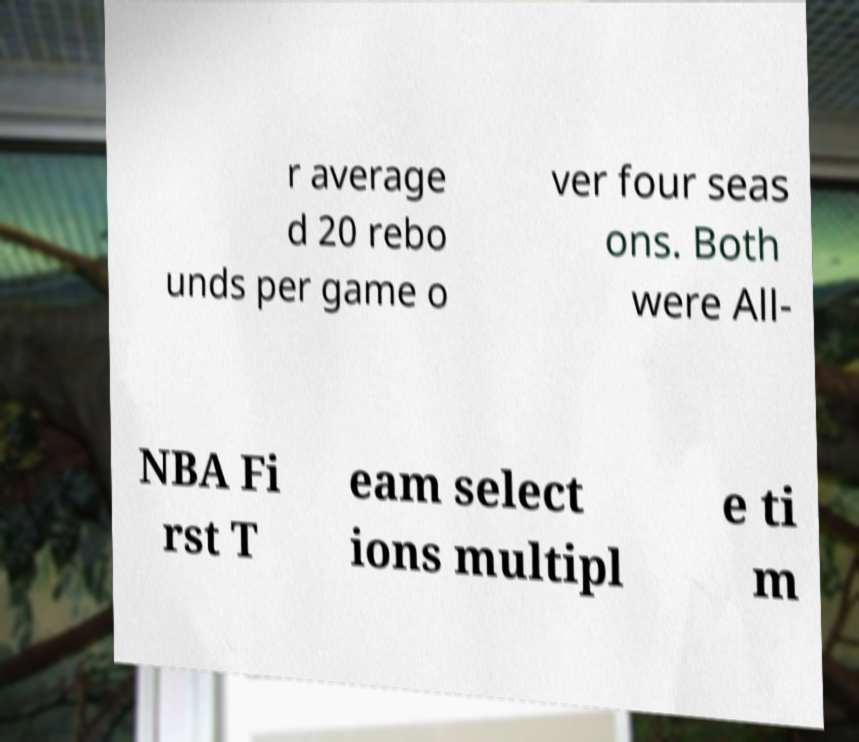Could you extract and type out the text from this image? r average d 20 rebo unds per game o ver four seas ons. Both were All- NBA Fi rst T eam select ions multipl e ti m 